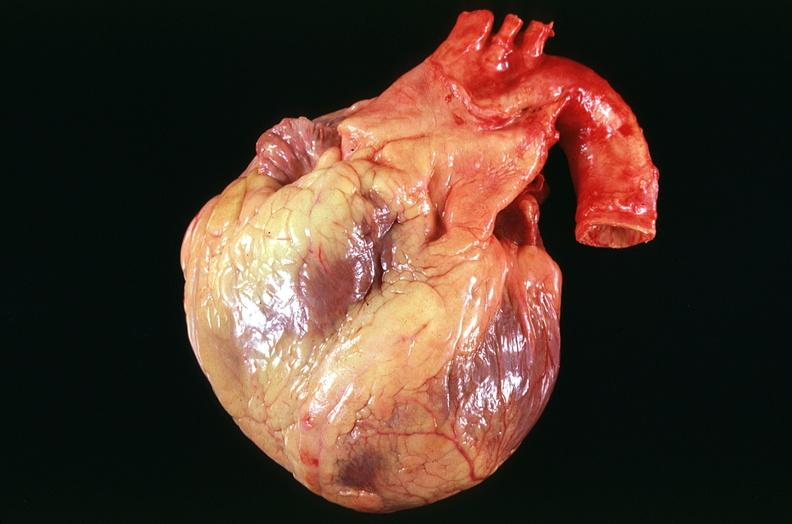what is present?
Answer the question using a single word or phrase. Cardiovascular 